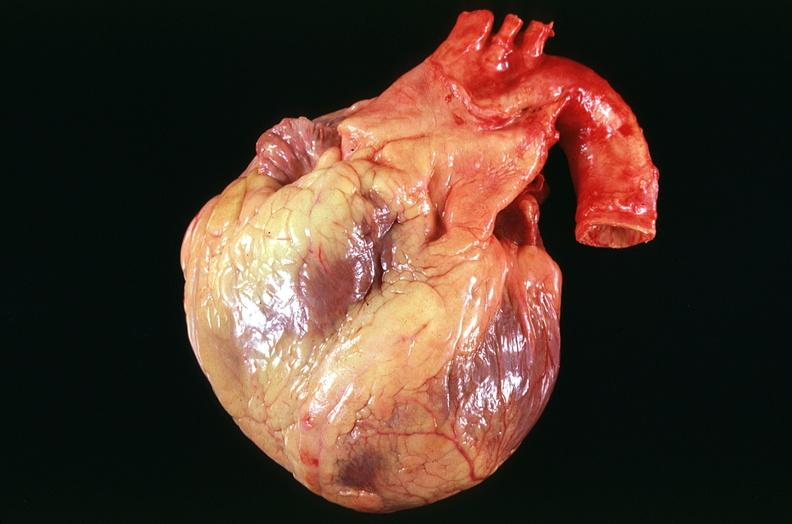what is present?
Answer the question using a single word or phrase. Cardiovascular 